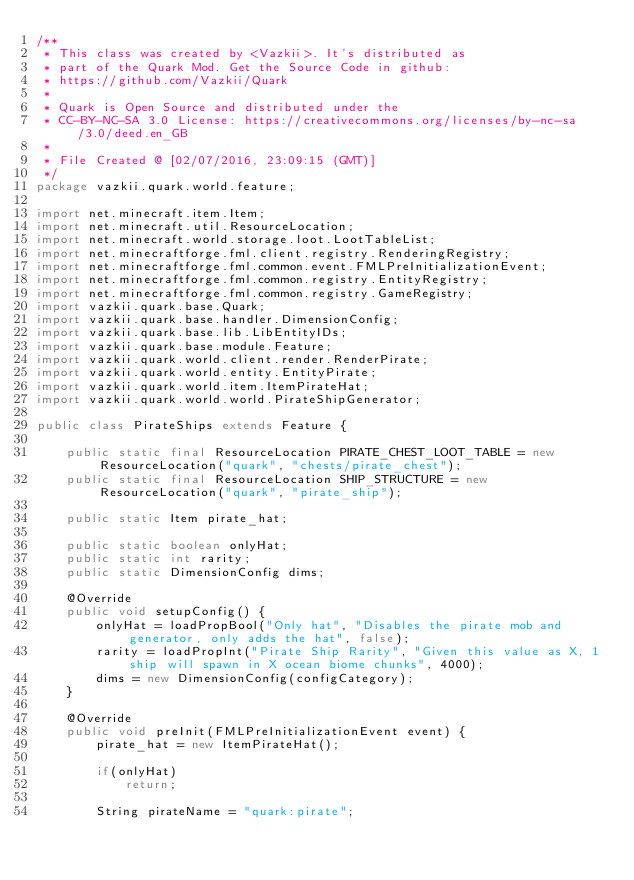<code> <loc_0><loc_0><loc_500><loc_500><_Java_>/**
 * This class was created by <Vazkii>. It's distributed as
 * part of the Quark Mod. Get the Source Code in github:
 * https://github.com/Vazkii/Quark
 *
 * Quark is Open Source and distributed under the
 * CC-BY-NC-SA 3.0 License: https://creativecommons.org/licenses/by-nc-sa/3.0/deed.en_GB
 *
 * File Created @ [02/07/2016, 23:09:15 (GMT)]
 */
package vazkii.quark.world.feature;

import net.minecraft.item.Item;
import net.minecraft.util.ResourceLocation;
import net.minecraft.world.storage.loot.LootTableList;
import net.minecraftforge.fml.client.registry.RenderingRegistry;
import net.minecraftforge.fml.common.event.FMLPreInitializationEvent;
import net.minecraftforge.fml.common.registry.EntityRegistry;
import net.minecraftforge.fml.common.registry.GameRegistry;
import vazkii.quark.base.Quark;
import vazkii.quark.base.handler.DimensionConfig;
import vazkii.quark.base.lib.LibEntityIDs;
import vazkii.quark.base.module.Feature;
import vazkii.quark.world.client.render.RenderPirate;
import vazkii.quark.world.entity.EntityPirate;
import vazkii.quark.world.item.ItemPirateHat;
import vazkii.quark.world.world.PirateShipGenerator;

public class PirateShips extends Feature {

	public static final ResourceLocation PIRATE_CHEST_LOOT_TABLE = new ResourceLocation("quark", "chests/pirate_chest");
	public static final ResourceLocation SHIP_STRUCTURE = new ResourceLocation("quark", "pirate_ship");

	public static Item pirate_hat;

	public static boolean onlyHat;
	public static int rarity;
	public static DimensionConfig dims;

	@Override
	public void setupConfig() {
		onlyHat = loadPropBool("Only hat", "Disables the pirate mob and generator, only adds the hat", false);
		rarity = loadPropInt("Pirate Ship Rarity", "Given this value as X, 1 ship will spawn in X ocean biome chunks", 4000);
		dims = new DimensionConfig(configCategory);
	}

	@Override
	public void preInit(FMLPreInitializationEvent event) {
		pirate_hat = new ItemPirateHat();

		if(onlyHat)
			return;
		
		String pirateName = "quark:pirate";</code> 